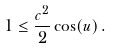<formula> <loc_0><loc_0><loc_500><loc_500>1 \leq \frac { c ^ { 2 } } { 2 } \cos ( u ) \, .</formula> 